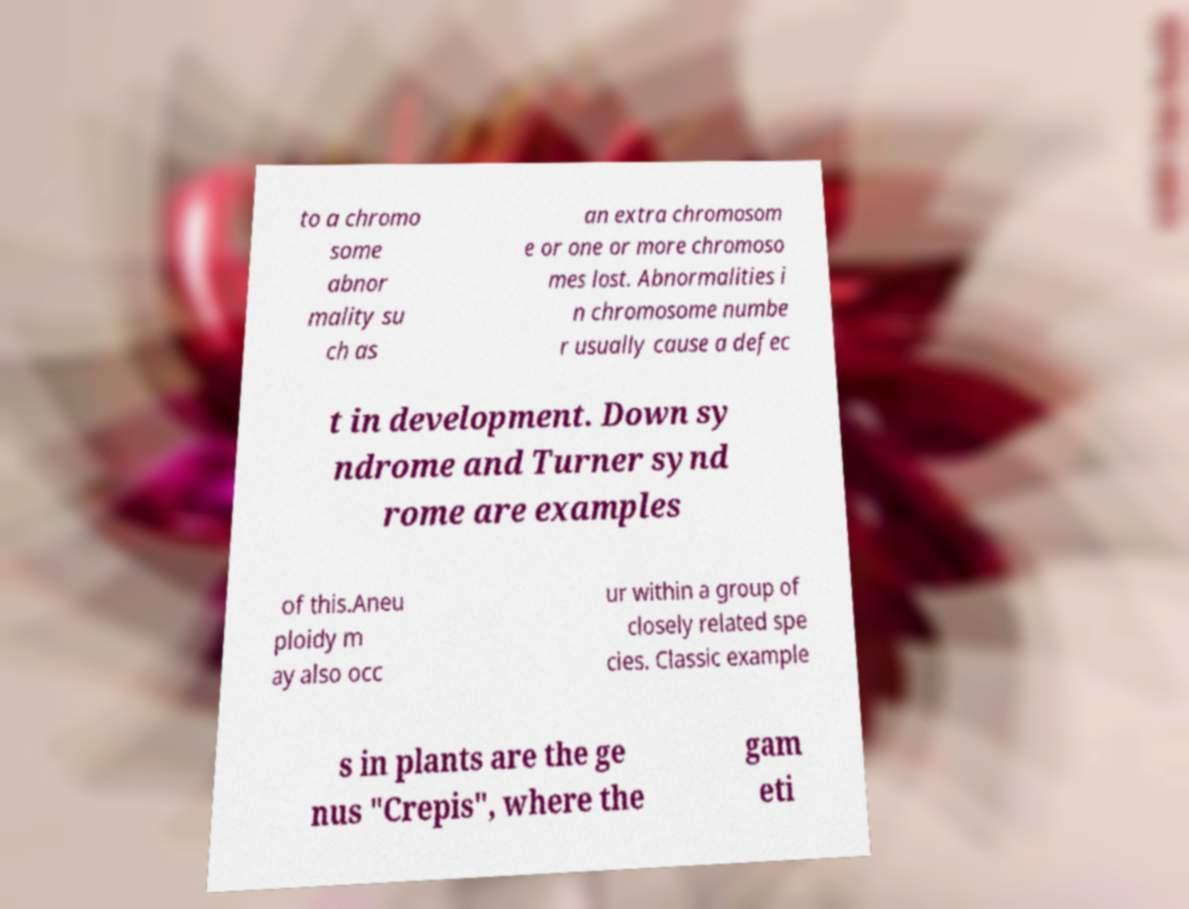For documentation purposes, I need the text within this image transcribed. Could you provide that? to a chromo some abnor mality su ch as an extra chromosom e or one or more chromoso mes lost. Abnormalities i n chromosome numbe r usually cause a defec t in development. Down sy ndrome and Turner synd rome are examples of this.Aneu ploidy m ay also occ ur within a group of closely related spe cies. Classic example s in plants are the ge nus "Crepis", where the gam eti 